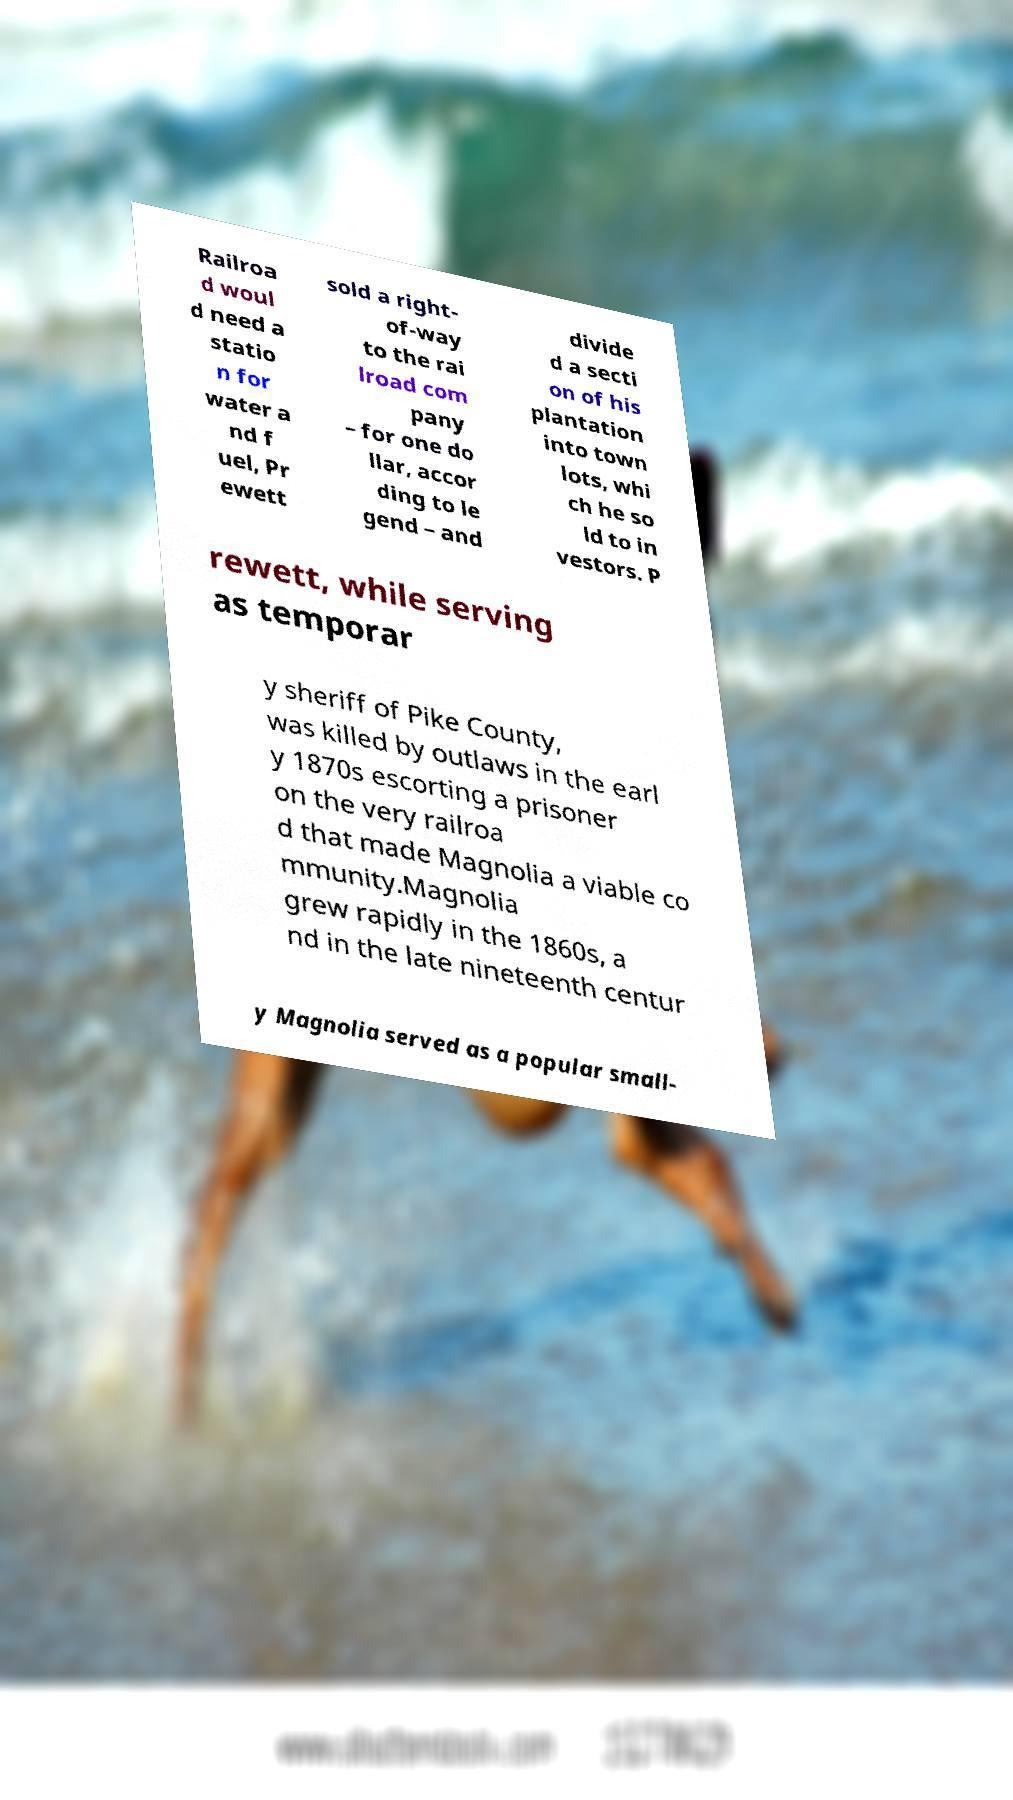I need the written content from this picture converted into text. Can you do that? Railroa d woul d need a statio n for water a nd f uel, Pr ewett sold a right- of-way to the rai lroad com pany – for one do llar, accor ding to le gend – and divide d a secti on of his plantation into town lots, whi ch he so ld to in vestors. P rewett, while serving as temporar y sheriff of Pike County, was killed by outlaws in the earl y 1870s escorting a prisoner on the very railroa d that made Magnolia a viable co mmunity.Magnolia grew rapidly in the 1860s, a nd in the late nineteenth centur y Magnolia served as a popular small- 